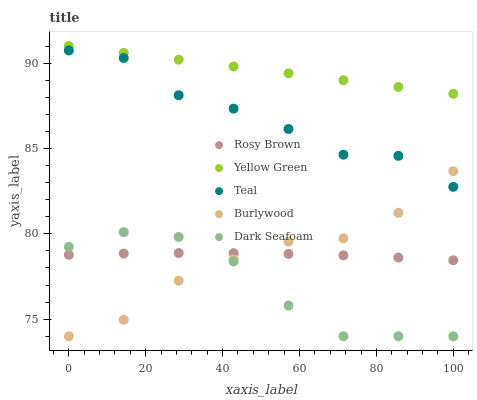Does Dark Seafoam have the minimum area under the curve?
Answer yes or no. Yes. Does Yellow Green have the maximum area under the curve?
Answer yes or no. Yes. Does Rosy Brown have the minimum area under the curve?
Answer yes or no. No. Does Rosy Brown have the maximum area under the curve?
Answer yes or no. No. Is Yellow Green the smoothest?
Answer yes or no. Yes. Is Teal the roughest?
Answer yes or no. Yes. Is Dark Seafoam the smoothest?
Answer yes or no. No. Is Dark Seafoam the roughest?
Answer yes or no. No. Does Burlywood have the lowest value?
Answer yes or no. Yes. Does Rosy Brown have the lowest value?
Answer yes or no. No. Does Yellow Green have the highest value?
Answer yes or no. Yes. Does Dark Seafoam have the highest value?
Answer yes or no. No. Is Burlywood less than Yellow Green?
Answer yes or no. Yes. Is Teal greater than Rosy Brown?
Answer yes or no. Yes. Does Teal intersect Burlywood?
Answer yes or no. Yes. Is Teal less than Burlywood?
Answer yes or no. No. Is Teal greater than Burlywood?
Answer yes or no. No. Does Burlywood intersect Yellow Green?
Answer yes or no. No. 